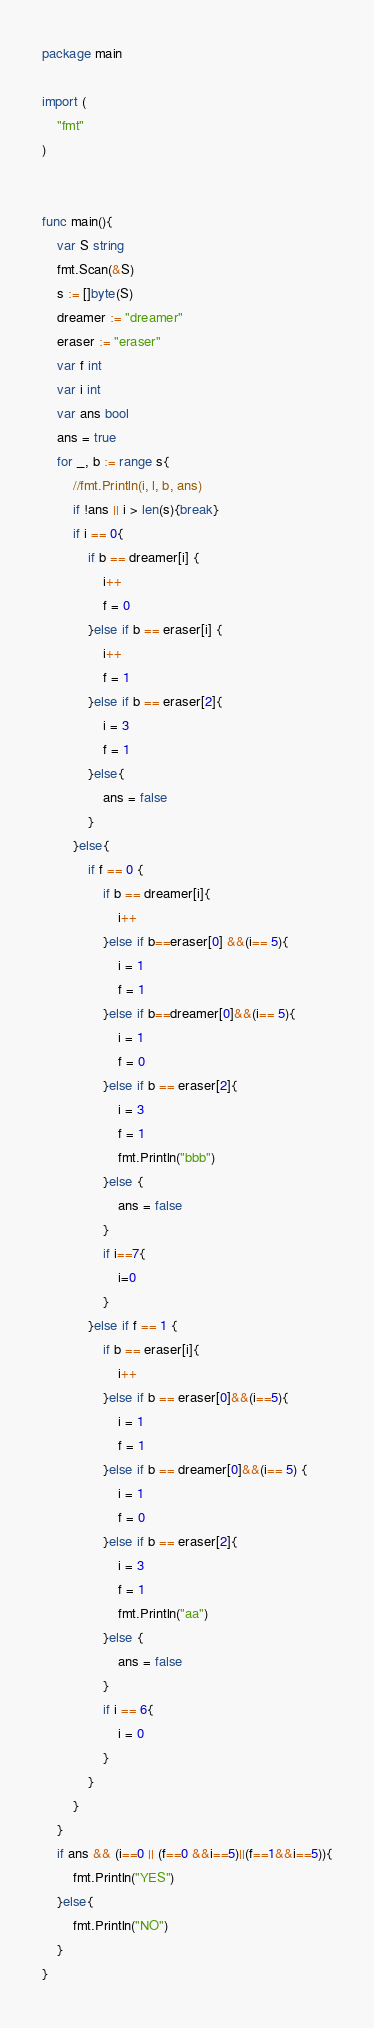<code> <loc_0><loc_0><loc_500><loc_500><_Go_>package main

import (
	"fmt"
)


func main(){
	var S string
	fmt.Scan(&S)
	s := []byte(S)
	dreamer := "dreamer"
	eraser := "eraser"
	var f int
	var i int
	var ans bool
	ans = true
	for _, b := range s{
		//fmt.Println(i, l, b, ans)
		if !ans || i > len(s){break}
		if i == 0{
			if b == dreamer[i] {
				i++
				f = 0
			}else if b == eraser[i] {
				i++
				f = 1
			}else if b == eraser[2]{
				i = 3
				f = 1
			}else{
				ans = false
			}
		}else{
			if f == 0 {
				if b == dreamer[i]{
					i++
				}else if b==eraser[0] &&(i== 5){
					i = 1
					f = 1
				}else if b==dreamer[0]&&(i== 5){
					i = 1
					f = 0
				}else if b == eraser[2]{
					i = 3
					f = 1
					fmt.Println("bbb")
				}else {
					ans = false
				}
				if i==7{
					i=0
				}
			}else if f == 1 {
				if b == eraser[i]{
					i++
				}else if b == eraser[0]&&(i==5){
					i = 1
					f = 1
				}else if b == dreamer[0]&&(i== 5) {
					i = 1
					f = 0
				}else if b == eraser[2]{
					i = 3
					f = 1
					fmt.Println("aa")
				}else {
					ans = false
				}
				if i == 6{
					i = 0
				}
			}
		}
	}
	if ans && (i==0 || (f==0 &&i==5)||(f==1&&i==5)){
		fmt.Println("YES")
	}else{
		fmt.Println("NO")
	}
}</code> 